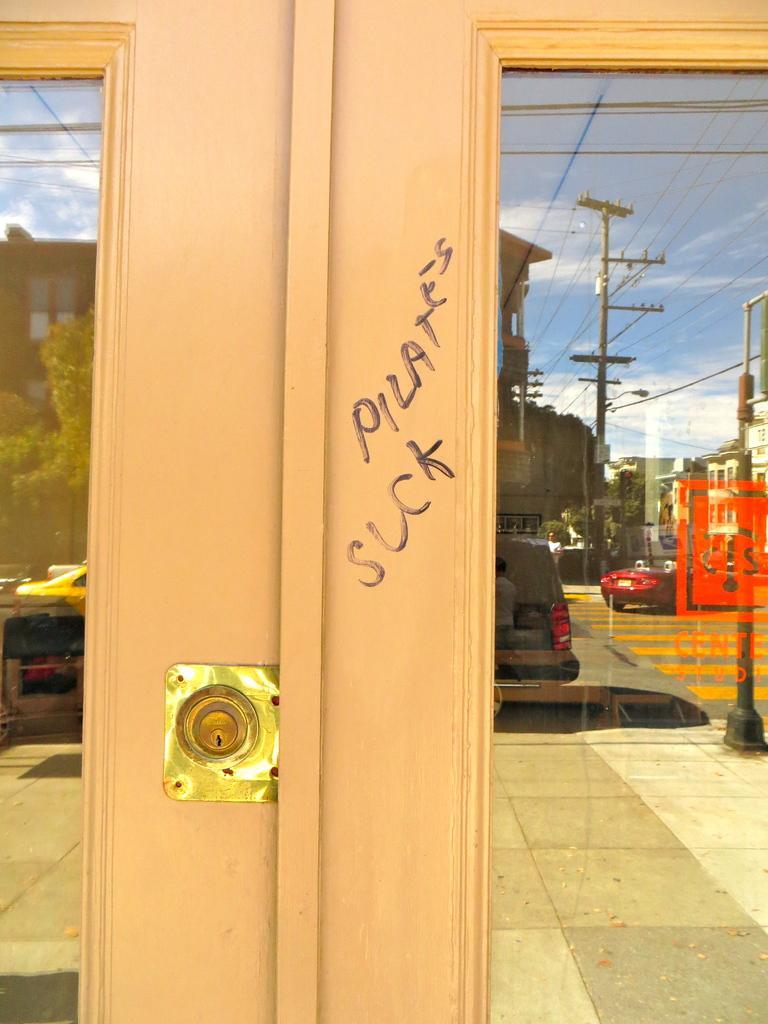Describe this image in one or two sentences. In this image there are glass windows and through the glass window we could see reflection of vehicles, poles, wires, buildings, trees, sky. At the bottom there is road, and on the glass windows there is some text. 